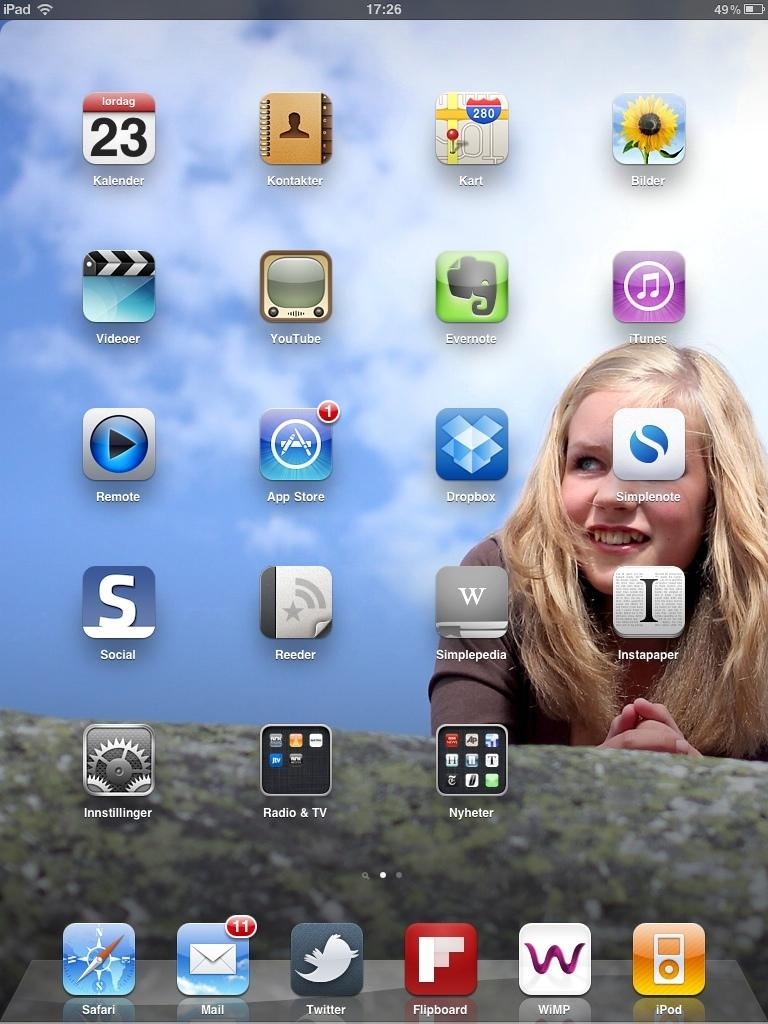Provide a one-sentence caption for the provided image. The dropbox app is located next to the App Store app. 